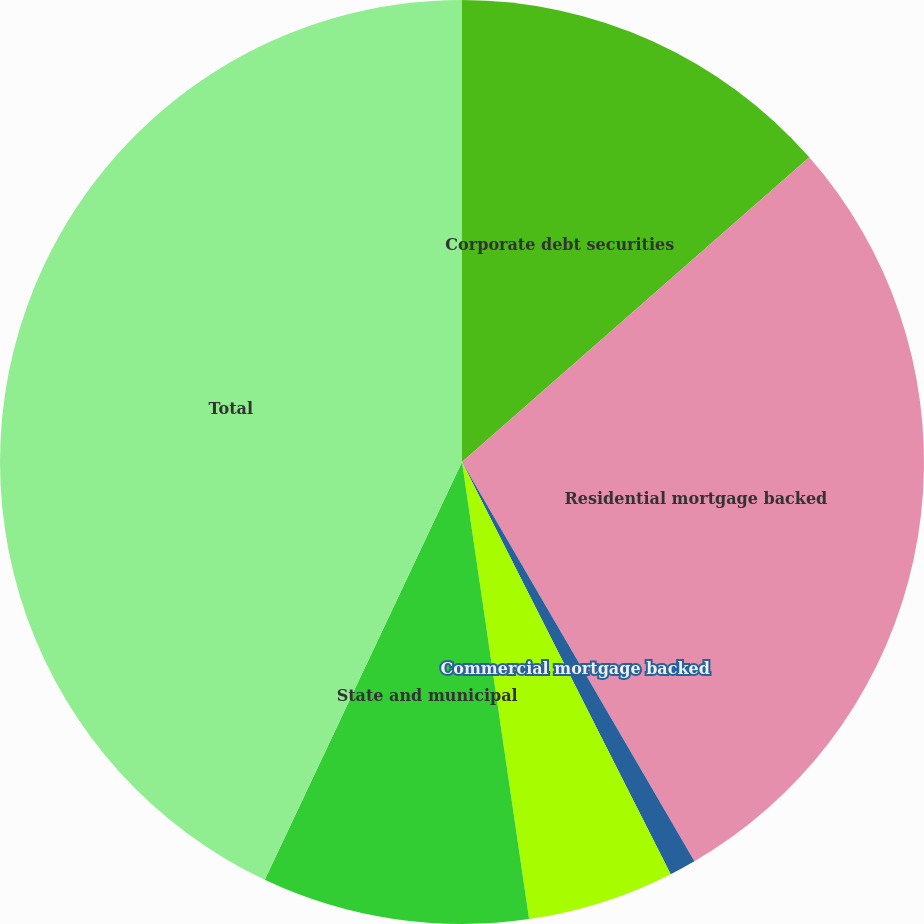Convert chart. <chart><loc_0><loc_0><loc_500><loc_500><pie_chart><fcel>Corporate debt securities<fcel>Residential mortgage backed<fcel>Commercial mortgage backed<fcel>Asset backed securities<fcel>State and municipal<fcel>Total<nl><fcel>13.54%<fcel>28.07%<fcel>0.93%<fcel>5.14%<fcel>9.34%<fcel>42.98%<nl></chart> 